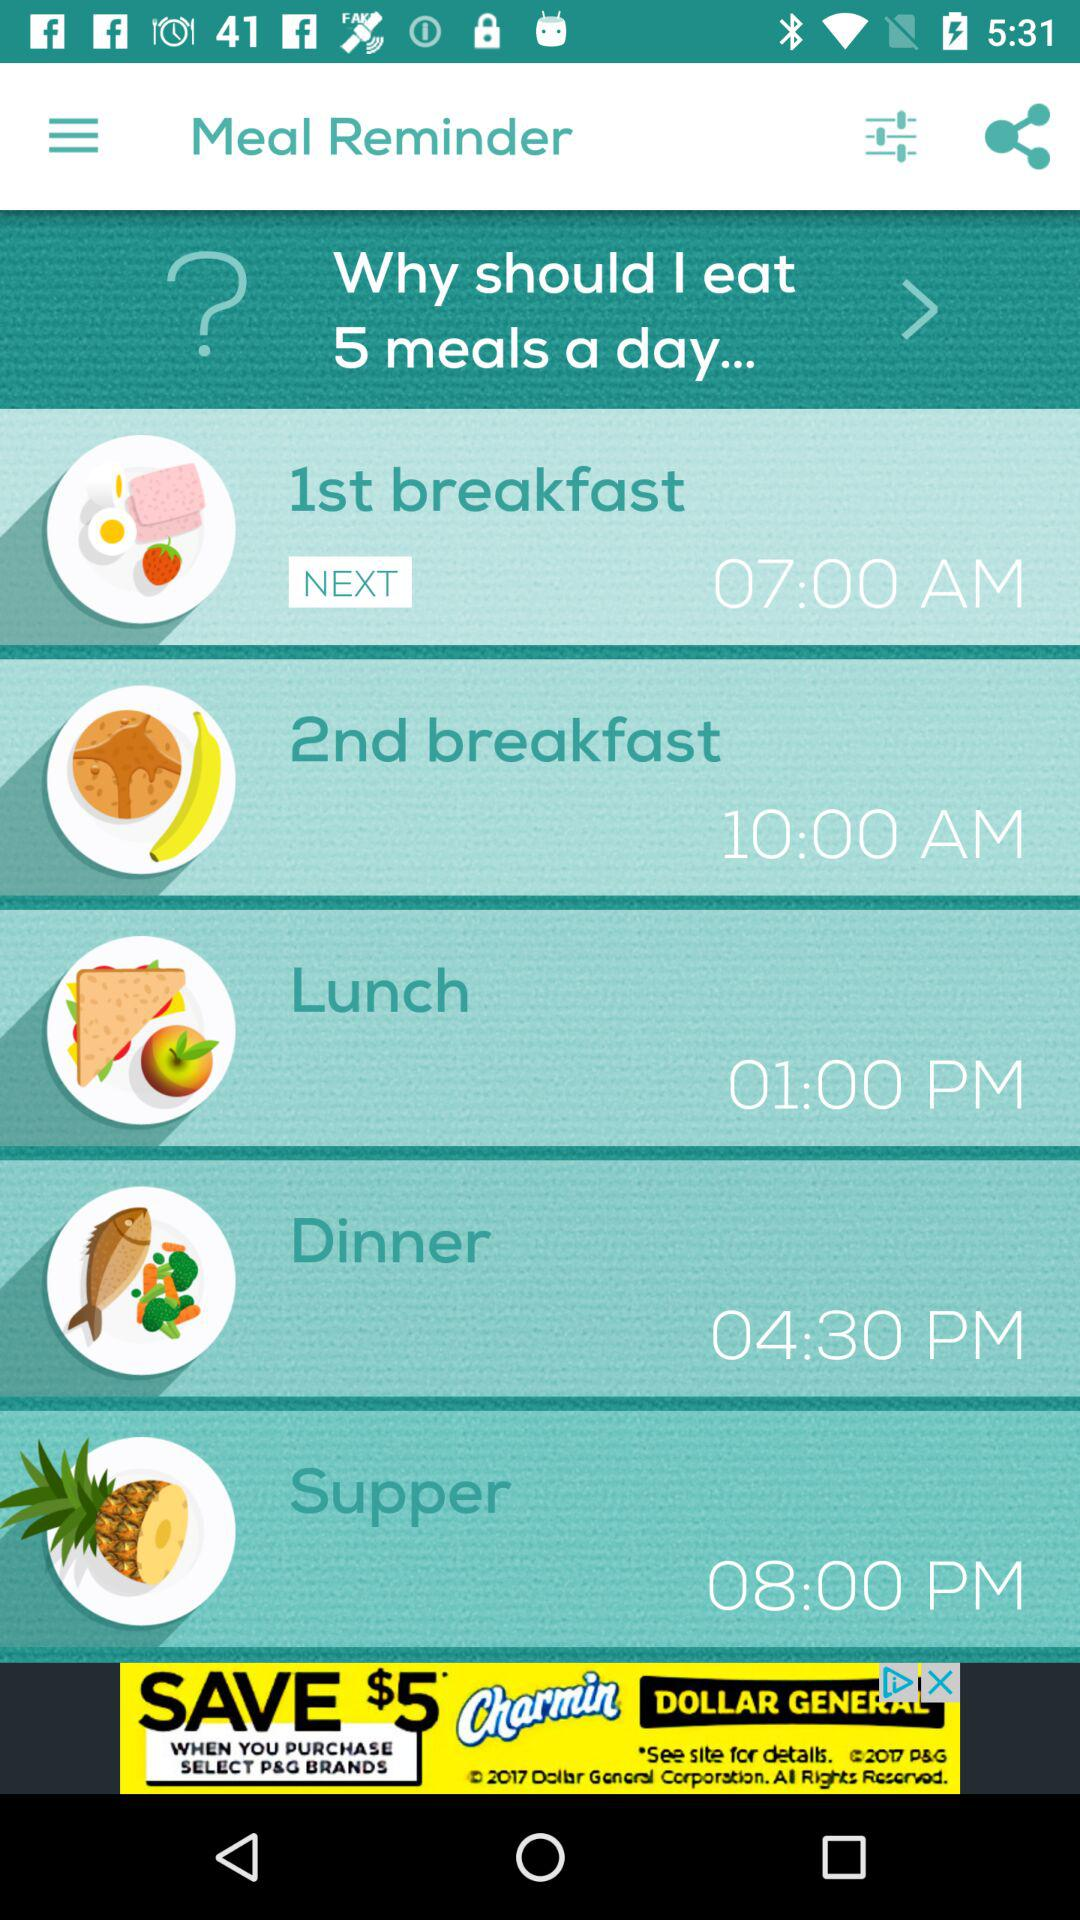How many meals are scheduled for the day? 5 